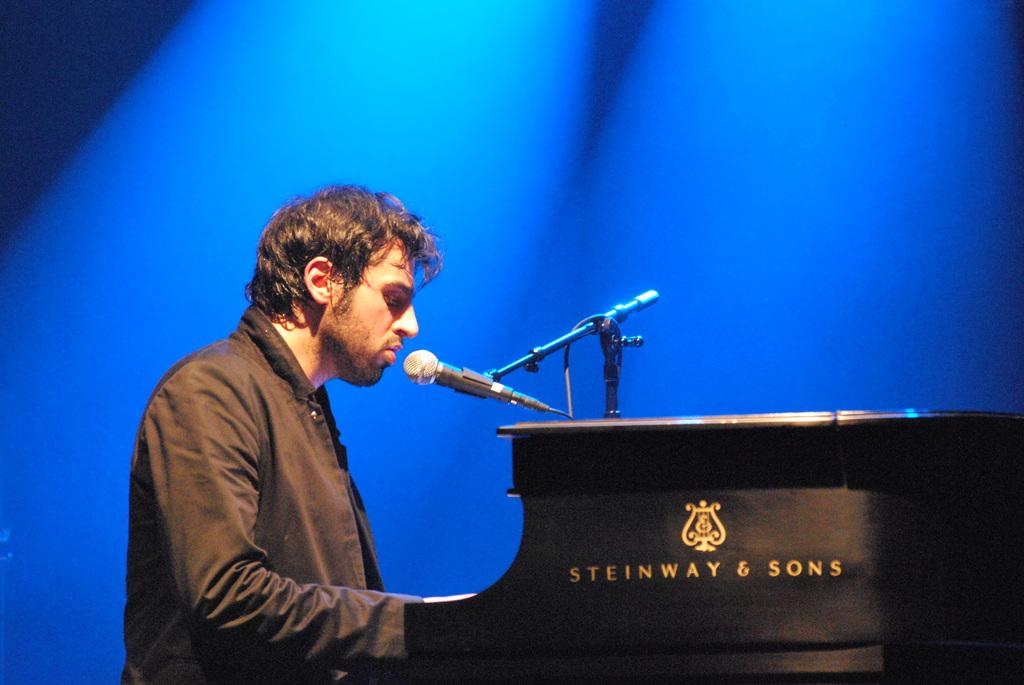Who or what is in the image? There is a person in the image. What object is present in the image that might be used for holding items or eating? There is a table in the image. What object is present in the image that is used for amplifying sound? A microphone (mic) is present in the image. What object is present in the image that might be used for holding the microphone? There is a stand in the image. What can be seen written on the table in the image? Something is written on the table. What color is the background of the image? The background of the image is blue. How many ice cubes are on the table in the image? There is no ice or ice cubes present in the image. What type of pin is being used by the person in the image? There is no pin visible in the image. 